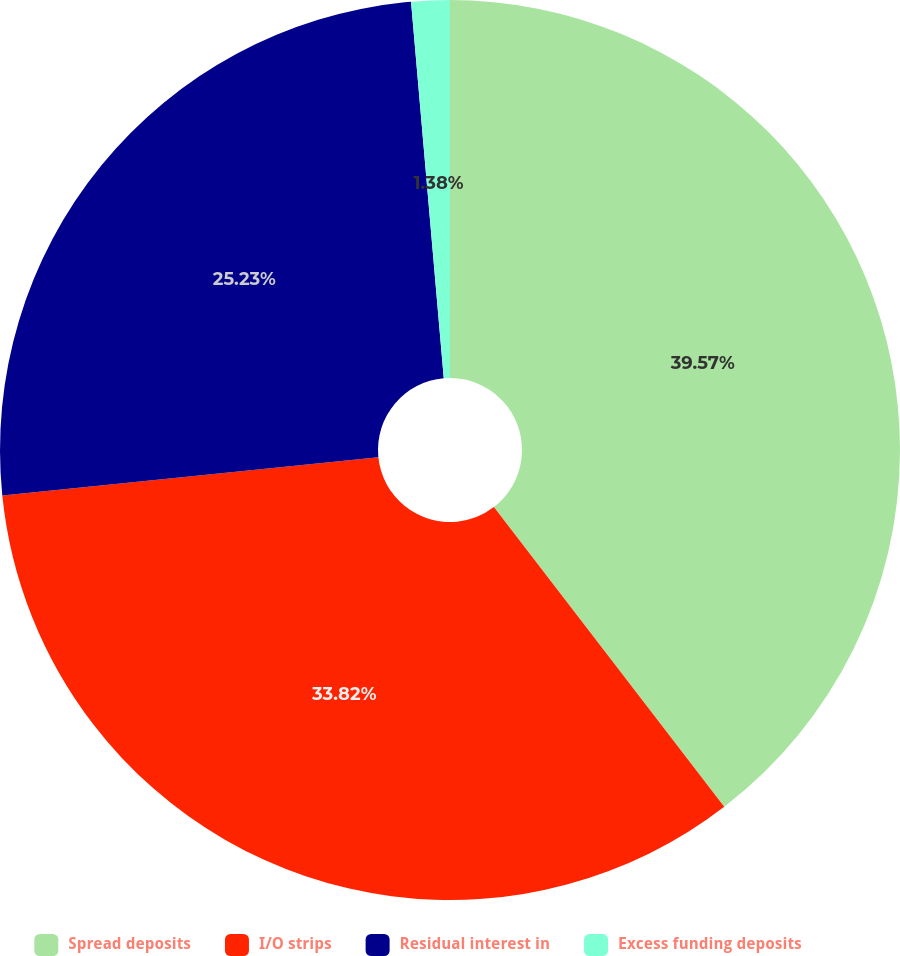Convert chart to OTSL. <chart><loc_0><loc_0><loc_500><loc_500><pie_chart><fcel>Spread deposits<fcel>I/O strips<fcel>Residual interest in<fcel>Excess funding deposits<nl><fcel>39.57%<fcel>33.82%<fcel>25.23%<fcel>1.38%<nl></chart> 